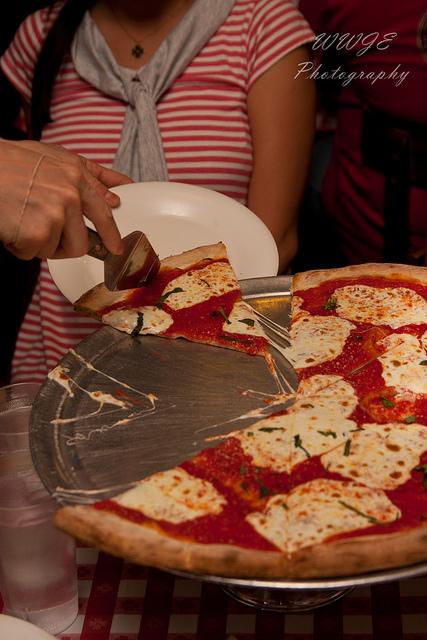Where is the blue scarf?
Short answer required. Around neck. Is there fruit shown in this picture?
Concise answer only. No. How many cups of sugar in the recipe?
Give a very brief answer. 0. Where is the pizza?
Be succinct. On tray. How many pieces are missing?
Answer briefly. 2. What utensils can be seen in this picture?
Answer briefly. Spatula. How many pieces of pizza are left?
Keep it brief. 6. What color are the stripes on the person's shirt?
Quick response, please. Red. Is there corn on this pizza?
Write a very short answer. No. How much pizza is left?
Write a very short answer. 3/4. Is there a white plate?
Concise answer only. Yes. Is the background in focus?
Be succinct. Yes. Is this a cheese pizza?
Concise answer only. Yes. Is this a big slice of pizza?
Give a very brief answer. Yes. Has anyone ate any pizza yet?
Be succinct. Yes. What is the white substance on the pan surrounding the uncooked pizza?
Answer briefly. Cheese. 